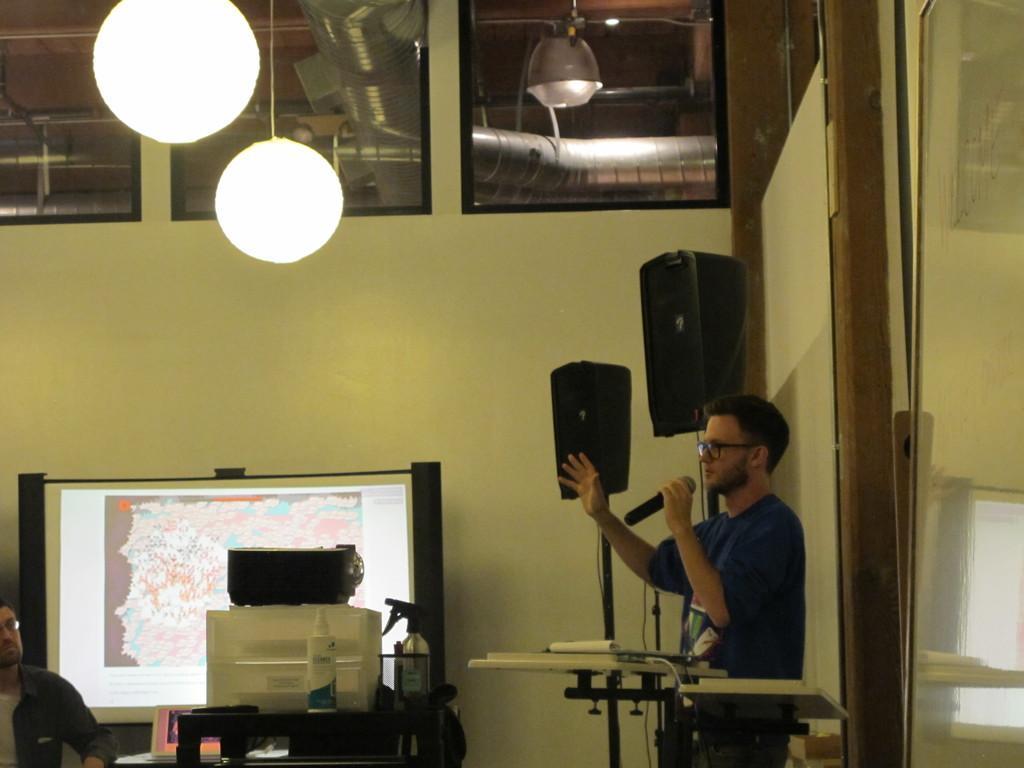Please provide a concise description of this image. As we can see in the image there is a wall, lights, sound box, a man holding mic, box and screen. 